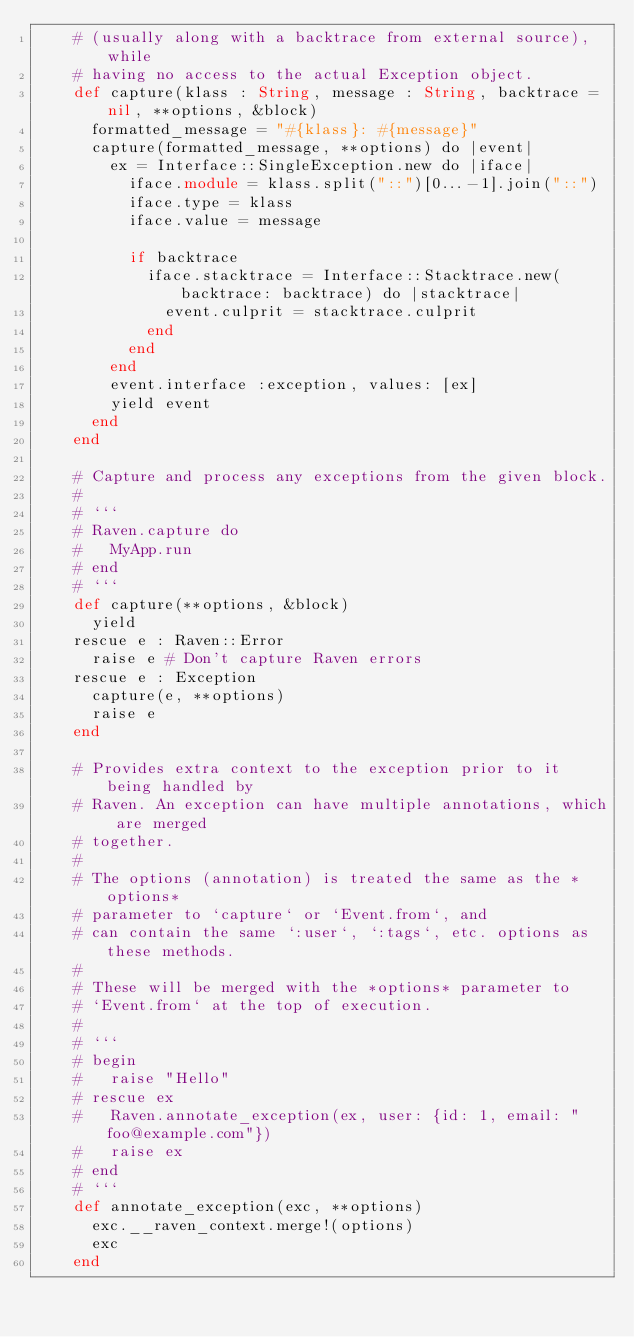Convert code to text. <code><loc_0><loc_0><loc_500><loc_500><_Crystal_>    # (usually along with a backtrace from external source), while
    # having no access to the actual Exception object.
    def capture(klass : String, message : String, backtrace = nil, **options, &block)
      formatted_message = "#{klass}: #{message}"
      capture(formatted_message, **options) do |event|
        ex = Interface::SingleException.new do |iface|
          iface.module = klass.split("::")[0...-1].join("::")
          iface.type = klass
          iface.value = message

          if backtrace
            iface.stacktrace = Interface::Stacktrace.new(backtrace: backtrace) do |stacktrace|
              event.culprit = stacktrace.culprit
            end
          end
        end
        event.interface :exception, values: [ex]
        yield event
      end
    end

    # Capture and process any exceptions from the given block.
    #
    # ```
    # Raven.capture do
    #   MyApp.run
    # end
    # ```
    def capture(**options, &block)
      yield
    rescue e : Raven::Error
      raise e # Don't capture Raven errors
    rescue e : Exception
      capture(e, **options)
      raise e
    end

    # Provides extra context to the exception prior to it being handled by
    # Raven. An exception can have multiple annotations, which are merged
    # together.
    #
    # The options (annotation) is treated the same as the *options*
    # parameter to `capture` or `Event.from`, and
    # can contain the same `:user`, `:tags`, etc. options as these methods.
    #
    # These will be merged with the *options* parameter to
    # `Event.from` at the top of execution.
    #
    # ```
    # begin
    #   raise "Hello"
    # rescue ex
    #   Raven.annotate_exception(ex, user: {id: 1, email: "foo@example.com"})
    #   raise ex
    # end
    # ```
    def annotate_exception(exc, **options)
      exc.__raven_context.merge!(options)
      exc
    end
</code> 